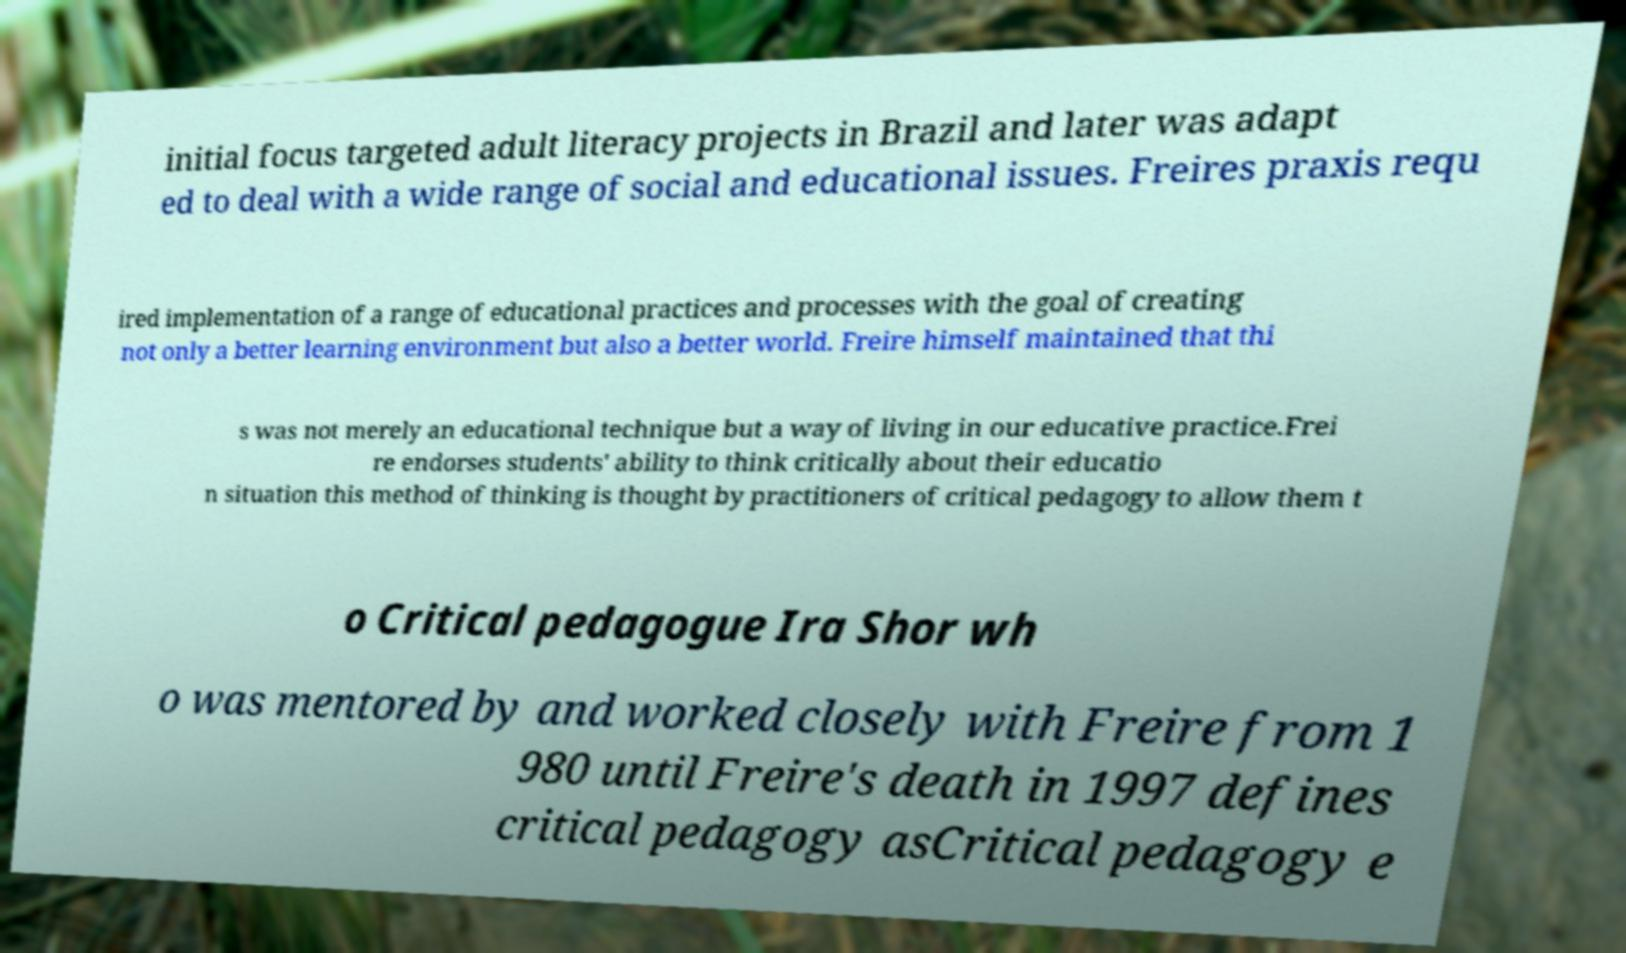There's text embedded in this image that I need extracted. Can you transcribe it verbatim? initial focus targeted adult literacy projects in Brazil and later was adapt ed to deal with a wide range of social and educational issues. Freires praxis requ ired implementation of a range of educational practices and processes with the goal of creating not only a better learning environment but also a better world. Freire himself maintained that thi s was not merely an educational technique but a way of living in our educative practice.Frei re endorses students' ability to think critically about their educatio n situation this method of thinking is thought by practitioners of critical pedagogy to allow them t o Critical pedagogue Ira Shor wh o was mentored by and worked closely with Freire from 1 980 until Freire's death in 1997 defines critical pedagogy asCritical pedagogy e 